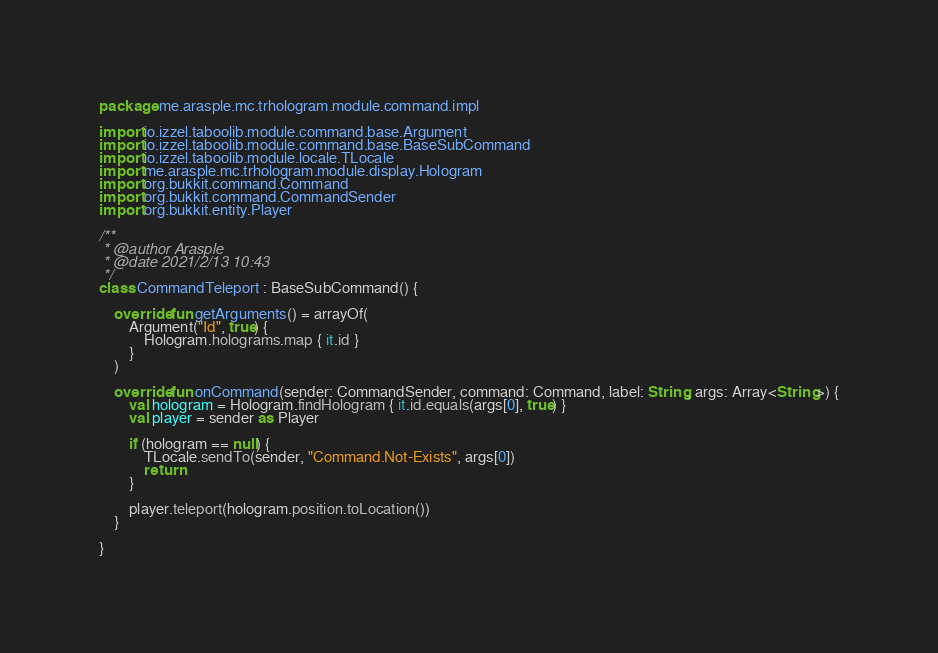Convert code to text. <code><loc_0><loc_0><loc_500><loc_500><_Kotlin_>package me.arasple.mc.trhologram.module.command.impl

import io.izzel.taboolib.module.command.base.Argument
import io.izzel.taboolib.module.command.base.BaseSubCommand
import io.izzel.taboolib.module.locale.TLocale
import me.arasple.mc.trhologram.module.display.Hologram
import org.bukkit.command.Command
import org.bukkit.command.CommandSender
import org.bukkit.entity.Player

/**
 * @author Arasple
 * @date 2021/2/13 10:43
 */
class CommandTeleport : BaseSubCommand() {

    override fun getArguments() = arrayOf(
        Argument("Id", true) {
            Hologram.holograms.map { it.id }
        }
    )

    override fun onCommand(sender: CommandSender, command: Command, label: String, args: Array<String>) {
        val hologram = Hologram.findHologram { it.id.equals(args[0], true) }
        val player = sender as Player

        if (hologram == null) {
            TLocale.sendTo(sender, "Command.Not-Exists", args[0])
            return
        }

        player.teleport(hologram.position.toLocation())
    }

}</code> 